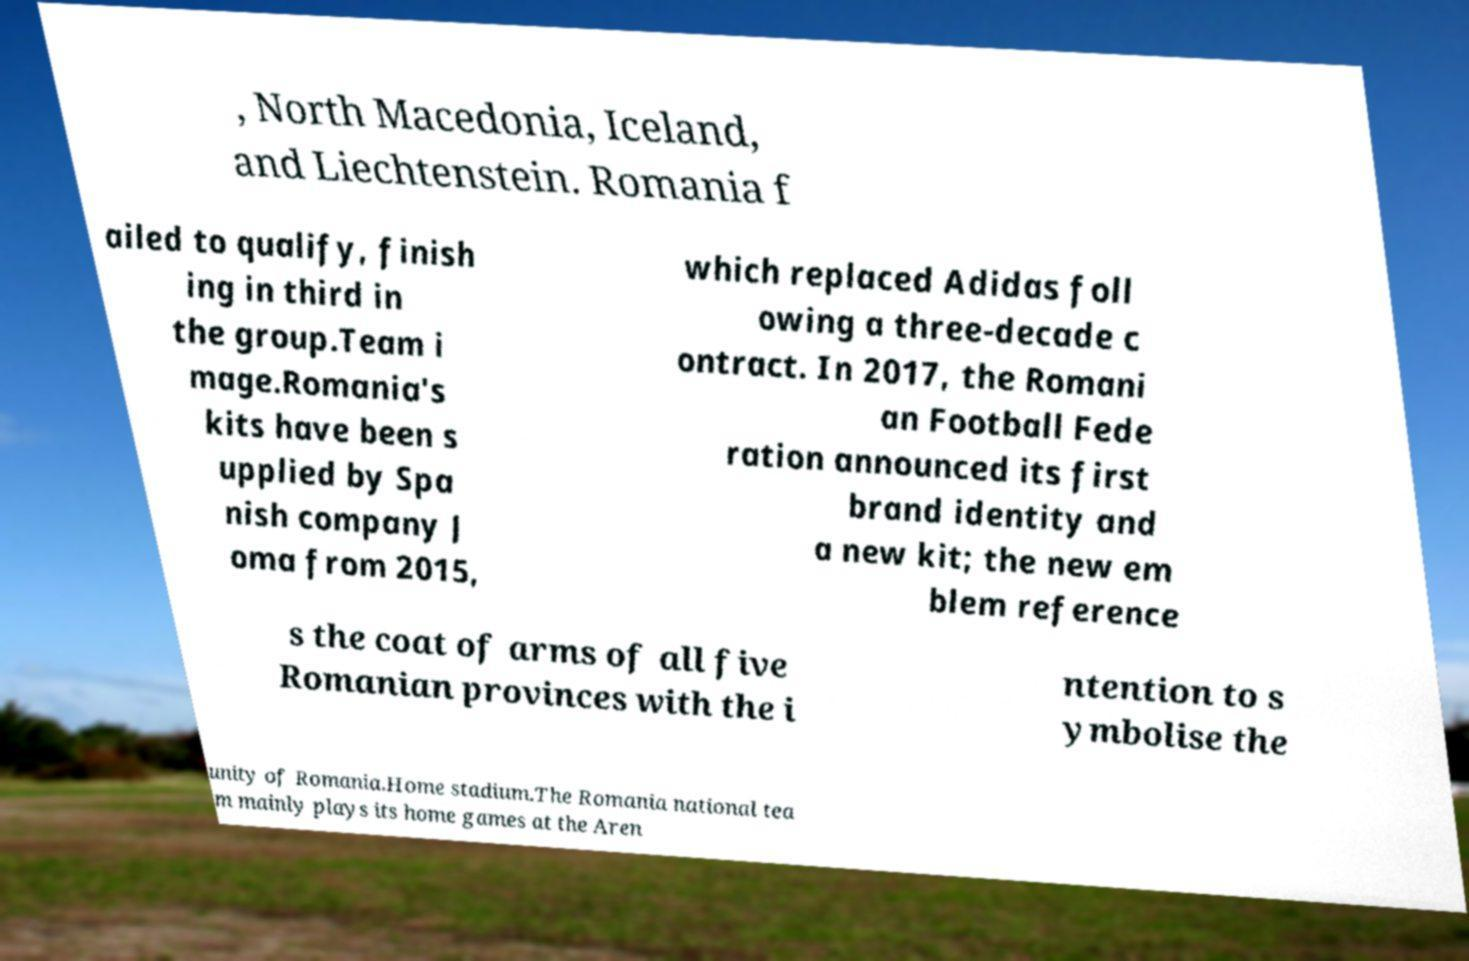Please read and relay the text visible in this image. What does it say? , North Macedonia, Iceland, and Liechtenstein. Romania f ailed to qualify, finish ing in third in the group.Team i mage.Romania's kits have been s upplied by Spa nish company J oma from 2015, which replaced Adidas foll owing a three-decade c ontract. In 2017, the Romani an Football Fede ration announced its first brand identity and a new kit; the new em blem reference s the coat of arms of all five Romanian provinces with the i ntention to s ymbolise the unity of Romania.Home stadium.The Romania national tea m mainly plays its home games at the Aren 